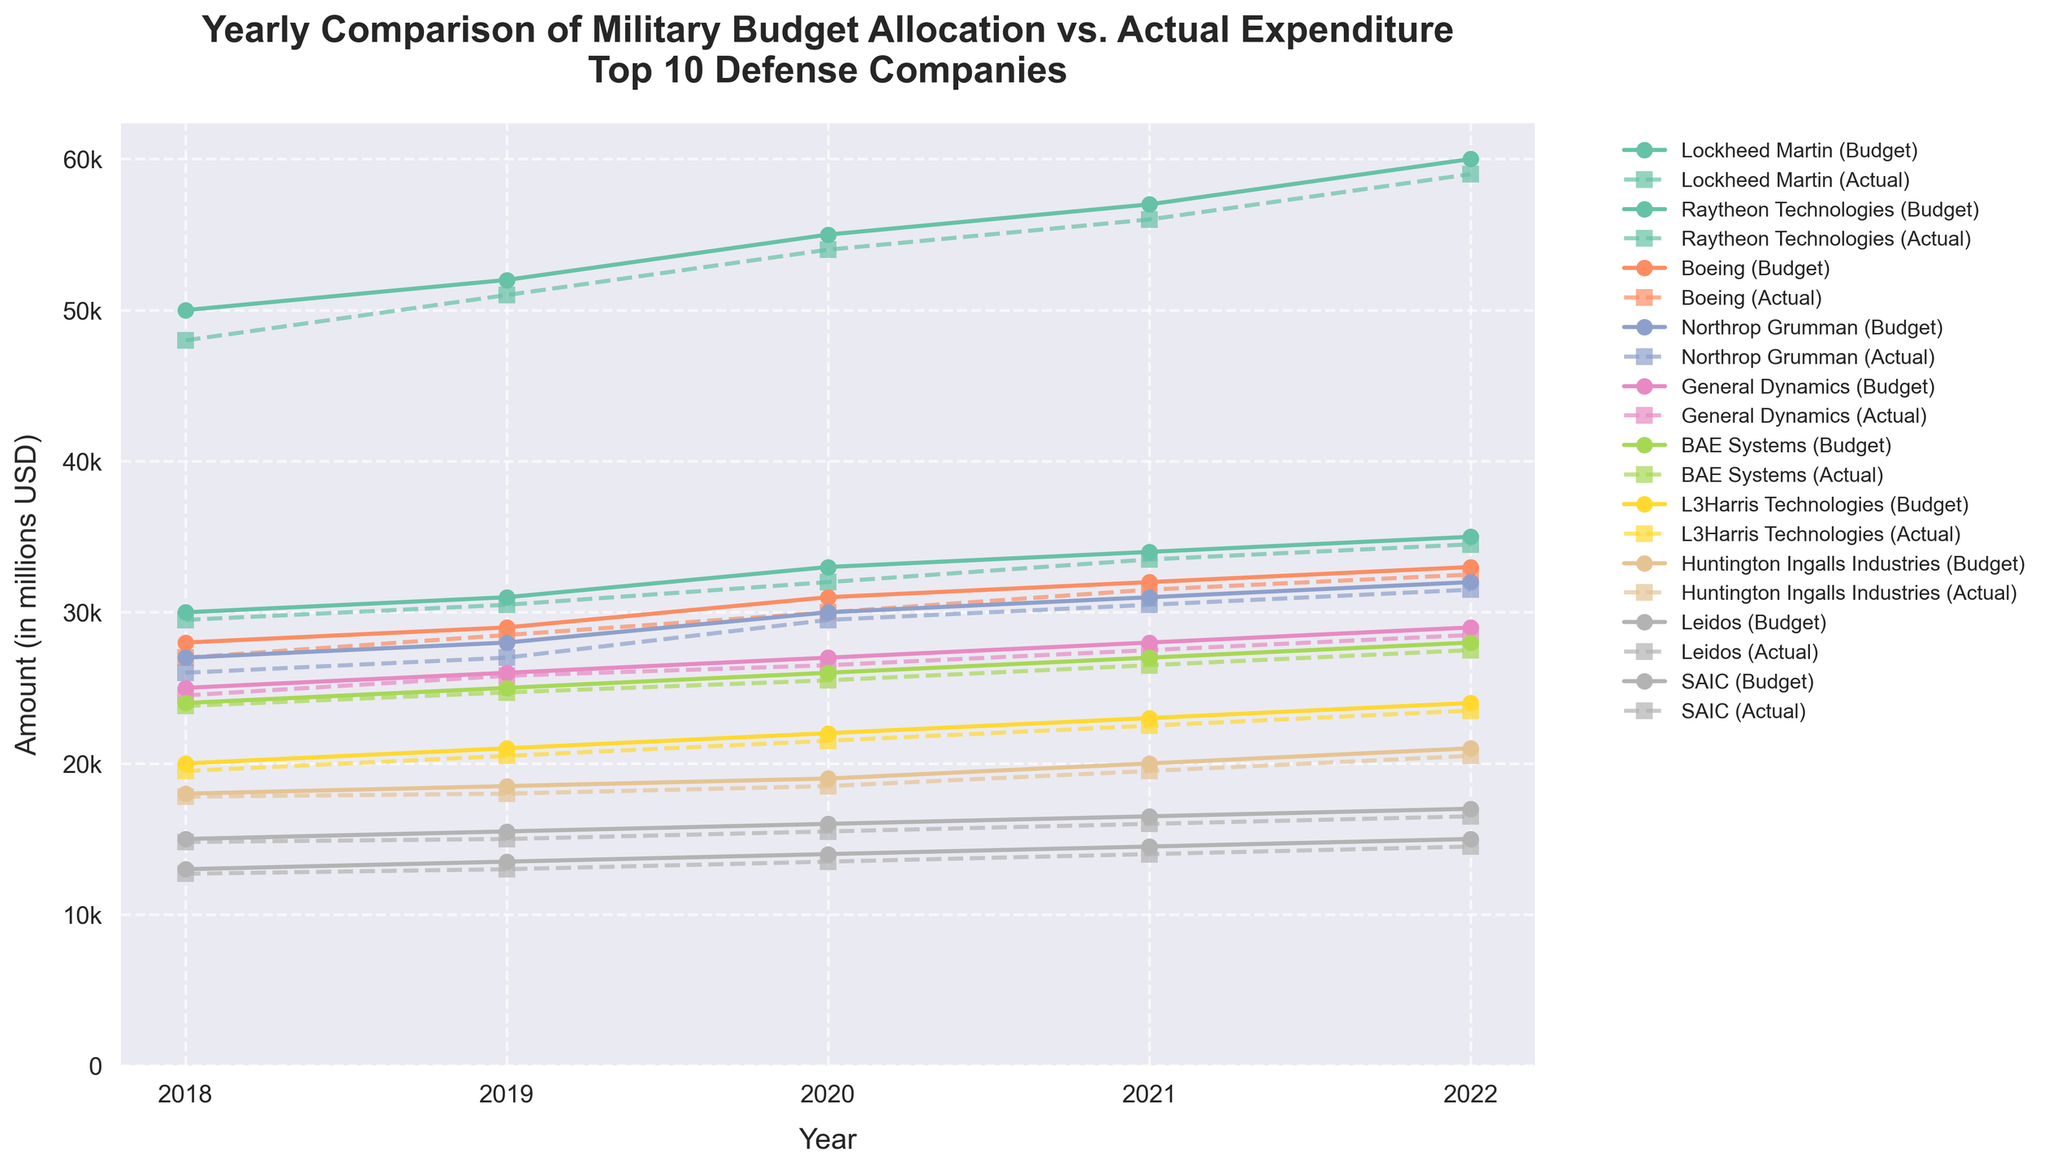What is the title of the figure? The title is located at the top of the figure and reads: "Yearly Comparison of Military Budget Allocation vs. Actual Expenditure\nTop 10 Defense Companies"
Answer: Yearly Comparison of Military Budget Allocation vs. Actual Expenditure\nTop 10 Defense Companies Which year shows the largest budget allocation for Lockheed Martin? Examine the plot lines for Lockheed Martin and identify the highest data point marked with a circle (budget allocation). The year with the largest budget allocation is 2022.
Answer: 2022 How does the actual expenditure of Boeing in 2020 compare to its budget allocation in the same year? Locate the data points for Boeing in 2020. The actual expenditure is marked with a square, and the budget allocation is marked with a circle. The actual expenditure ($30,000 million) is less than the budget allocation ($31,000 million).
Answer: Less than What is the average budget allocation for Raytheon Technologies from 2018 to 2022? Identify the budget allocations for Raytheon Technologies across the years 2018, 2019, 2020, 2021, and 2022. Sum these values (30,000 + 31,000 + 33,000 + 34,000 + 35,000) and divide by the number of years (5). The average budget allocation is 32,600 million.
Answer: 32,600 million Which company had a higher actual expenditure in 2021, Northrop Grumman or General Dynamics? Look at the 2021 data points for both companies. Compare the squares representing actual expenditure: Northrop Grumman (30,500 million) and General Dynamics (27,500 million). Northrop Grumman had a higher actual expenditure.
Answer: Northrop Grumman What is the budget allocation trend for Huntington Ingalls Industries from 2018 to 2022? Locate the data points for the budget allocation of Huntington Ingalls Industries across the years from 2018 to 2022. The budget allocation is increasing each year over this period.
Answer: Increasing Is there a year where SAIC's actual expenditure equals its budget allocation? SAIC's actual expenditures are always slightly less than its corresponding budget allocations across the years 2018 to 2022. Therefore, there is no year where they are equal.
Answer: No How much did Lockheed Martin exceed its budget allocation in 2022? Look at Lockheed Martin's data points for 2022. The budget allocation is 60,000 million and the actual expenditure is 59,000 million. Lockheed Martin did not exceed its budget in 2022; its actual expenditure was 1,000 million less than the budget.
Answer: None (it did not exceed) Compare the budget allocation of Leidos to L3Harris Technologies in 2020. Which company had a higher allocation? Identify the budget allocation data points for Leidos (16,000 million) and L3Harris Technologies (22,000 million) in 2020. L3Harris Technologies had a higher budget allocation.
Answer: L3Harris Technologies 